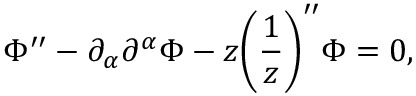Convert formula to latex. <formula><loc_0><loc_0><loc_500><loc_500>\Phi ^ { \prime \prime } - \partial _ { \alpha } \partial ^ { \alpha } \Phi - z \left ( \frac { 1 } { z } \right ) ^ { \prime \prime } \Phi = 0 ,</formula> 